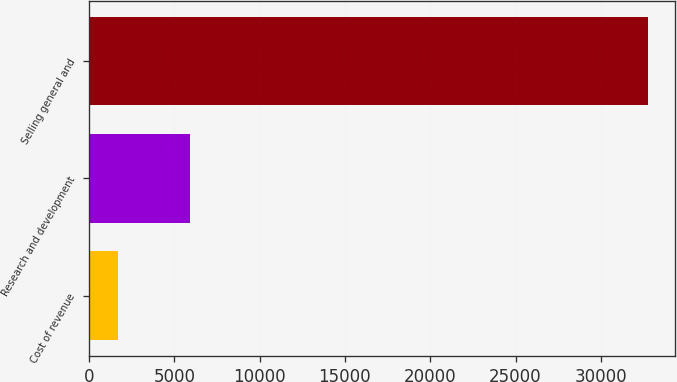Convert chart to OTSL. <chart><loc_0><loc_0><loc_500><loc_500><bar_chart><fcel>Cost of revenue<fcel>Research and development<fcel>Selling general and<nl><fcel>1721<fcel>5895<fcel>32737<nl></chart> 